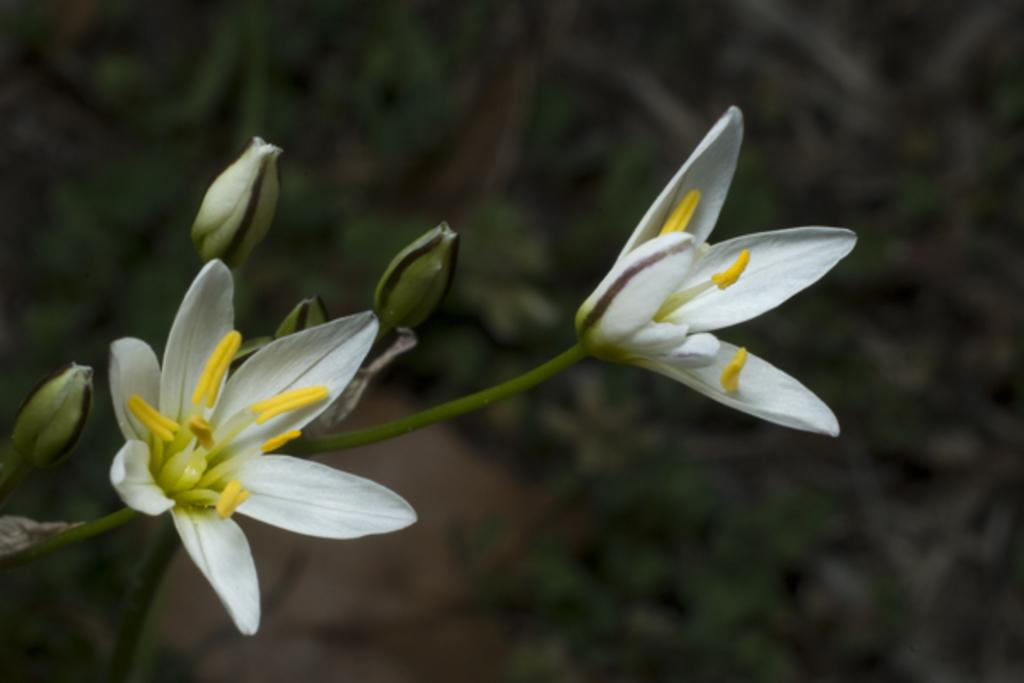What type of plant life is present in the image? There are flowers, buds, and stems in the image. Can you describe the stage of growth for the plants in the image? The plants in the image have buds, which suggests they are in the early stages of growth. What is the condition of the background in the image? The background of the image is blurry. What type of humor can be seen in the image? There is no humor present in the image; it features flowers, buds, and stems with a blurry background. 